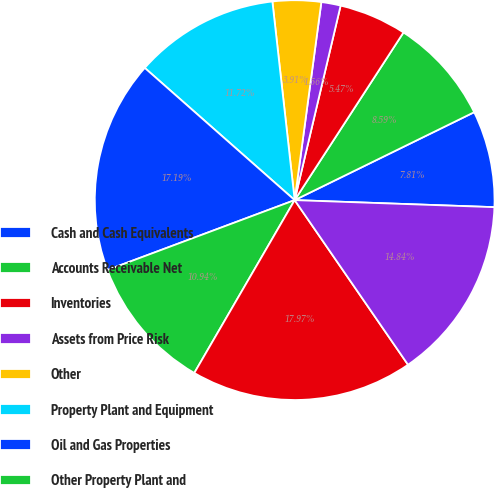Convert chart. <chart><loc_0><loc_0><loc_500><loc_500><pie_chart><fcel>Cash and Cash Equivalents<fcel>Accounts Receivable Net<fcel>Inventories<fcel>Assets from Price Risk<fcel>Other<fcel>Property Plant and Equipment<fcel>Oil and Gas Properties<fcel>Other Property Plant and<fcel>Total Property Plant and<fcel>Less Accumulated Depreciation<nl><fcel>7.81%<fcel>8.59%<fcel>5.47%<fcel>1.56%<fcel>3.91%<fcel>11.72%<fcel>17.19%<fcel>10.94%<fcel>17.97%<fcel>14.84%<nl></chart> 